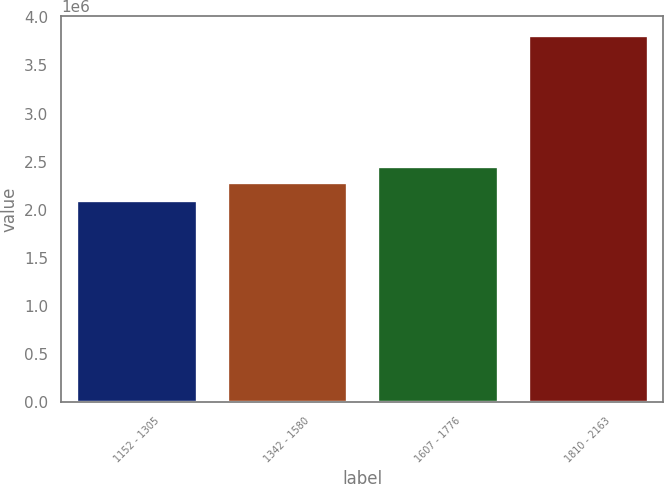<chart> <loc_0><loc_0><loc_500><loc_500><bar_chart><fcel>1152 - 1305<fcel>1342 - 1580<fcel>1607 - 1776<fcel>1810 - 2163<nl><fcel>2.10732e+06<fcel>2.28867e+06<fcel>2.45976e+06<fcel>3.81828e+06<nl></chart> 